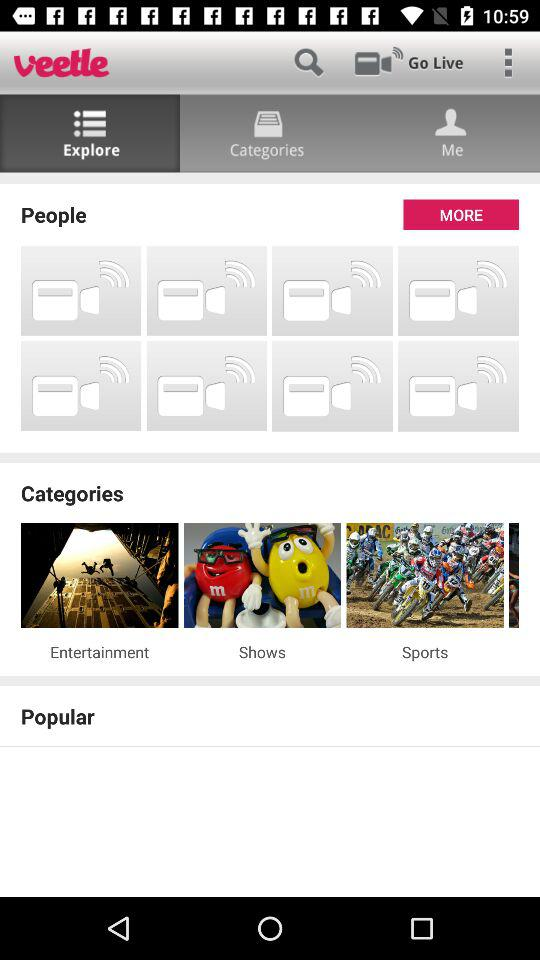What is the name of the application? The name of the application is "veetle". 